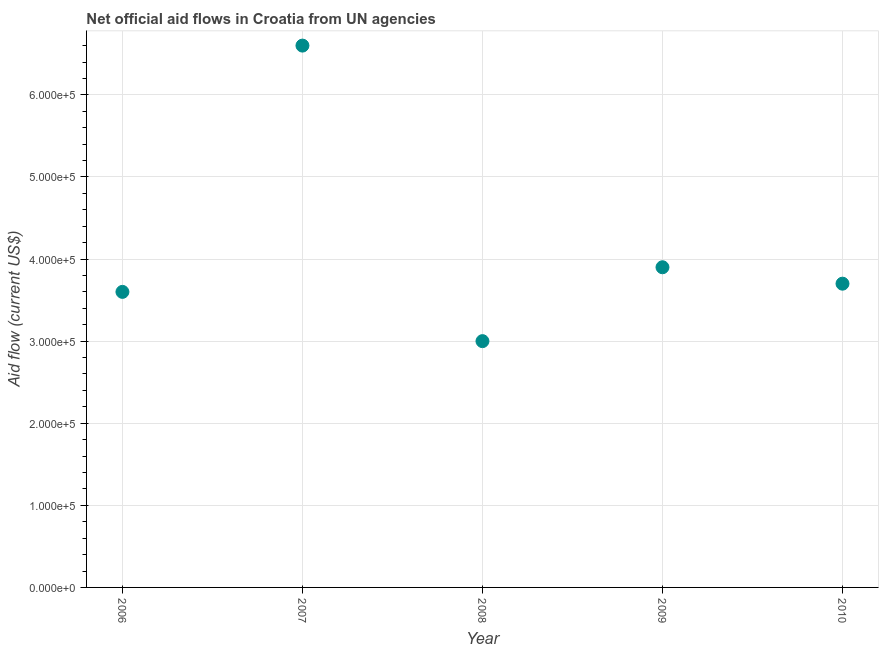What is the net official flows from un agencies in 2007?
Make the answer very short. 6.60e+05. Across all years, what is the maximum net official flows from un agencies?
Your answer should be very brief. 6.60e+05. Across all years, what is the minimum net official flows from un agencies?
Your answer should be compact. 3.00e+05. In which year was the net official flows from un agencies maximum?
Offer a very short reply. 2007. In which year was the net official flows from un agencies minimum?
Your response must be concise. 2008. What is the sum of the net official flows from un agencies?
Your response must be concise. 2.08e+06. What is the difference between the net official flows from un agencies in 2006 and 2009?
Your response must be concise. -3.00e+04. What is the average net official flows from un agencies per year?
Ensure brevity in your answer.  4.16e+05. What is the median net official flows from un agencies?
Ensure brevity in your answer.  3.70e+05. What is the ratio of the net official flows from un agencies in 2006 to that in 2009?
Offer a very short reply. 0.92. Is the difference between the net official flows from un agencies in 2007 and 2008 greater than the difference between any two years?
Ensure brevity in your answer.  Yes. Is the sum of the net official flows from un agencies in 2007 and 2009 greater than the maximum net official flows from un agencies across all years?
Provide a short and direct response. Yes. What is the difference between the highest and the lowest net official flows from un agencies?
Ensure brevity in your answer.  3.60e+05. Does the net official flows from un agencies monotonically increase over the years?
Ensure brevity in your answer.  No. How many dotlines are there?
Provide a succinct answer. 1. What is the difference between two consecutive major ticks on the Y-axis?
Offer a terse response. 1.00e+05. Are the values on the major ticks of Y-axis written in scientific E-notation?
Provide a short and direct response. Yes. Does the graph contain grids?
Give a very brief answer. Yes. What is the title of the graph?
Your answer should be compact. Net official aid flows in Croatia from UN agencies. What is the Aid flow (current US$) in 2006?
Offer a terse response. 3.60e+05. What is the Aid flow (current US$) in 2009?
Provide a short and direct response. 3.90e+05. What is the Aid flow (current US$) in 2010?
Offer a terse response. 3.70e+05. What is the difference between the Aid flow (current US$) in 2006 and 2008?
Keep it short and to the point. 6.00e+04. What is the difference between the Aid flow (current US$) in 2006 and 2009?
Offer a terse response. -3.00e+04. What is the difference between the Aid flow (current US$) in 2006 and 2010?
Keep it short and to the point. -10000. What is the difference between the Aid flow (current US$) in 2007 and 2008?
Provide a succinct answer. 3.60e+05. What is the difference between the Aid flow (current US$) in 2007 and 2010?
Offer a terse response. 2.90e+05. What is the difference between the Aid flow (current US$) in 2008 and 2009?
Provide a succinct answer. -9.00e+04. What is the ratio of the Aid flow (current US$) in 2006 to that in 2007?
Provide a succinct answer. 0.55. What is the ratio of the Aid flow (current US$) in 2006 to that in 2009?
Offer a terse response. 0.92. What is the ratio of the Aid flow (current US$) in 2007 to that in 2009?
Your answer should be compact. 1.69. What is the ratio of the Aid flow (current US$) in 2007 to that in 2010?
Provide a short and direct response. 1.78. What is the ratio of the Aid flow (current US$) in 2008 to that in 2009?
Offer a terse response. 0.77. What is the ratio of the Aid flow (current US$) in 2008 to that in 2010?
Make the answer very short. 0.81. What is the ratio of the Aid flow (current US$) in 2009 to that in 2010?
Offer a very short reply. 1.05. 